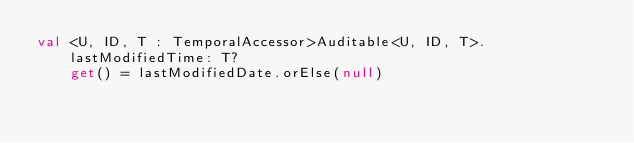Convert code to text. <code><loc_0><loc_0><loc_500><loc_500><_Kotlin_>val <U, ID, T : TemporalAccessor>Auditable<U, ID, T>.lastModifiedTime: T?
    get() = lastModifiedDate.orElse(null)
</code> 